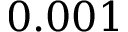<formula> <loc_0><loc_0><loc_500><loc_500>0 . 0 0 1</formula> 